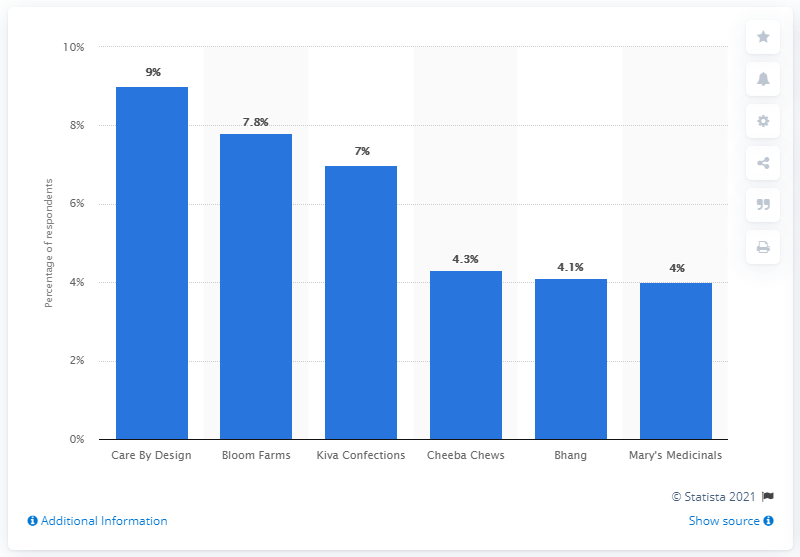List a handful of essential elements in this visual. Care By Design was the top marijuana-derived CBD brand in 2017. 